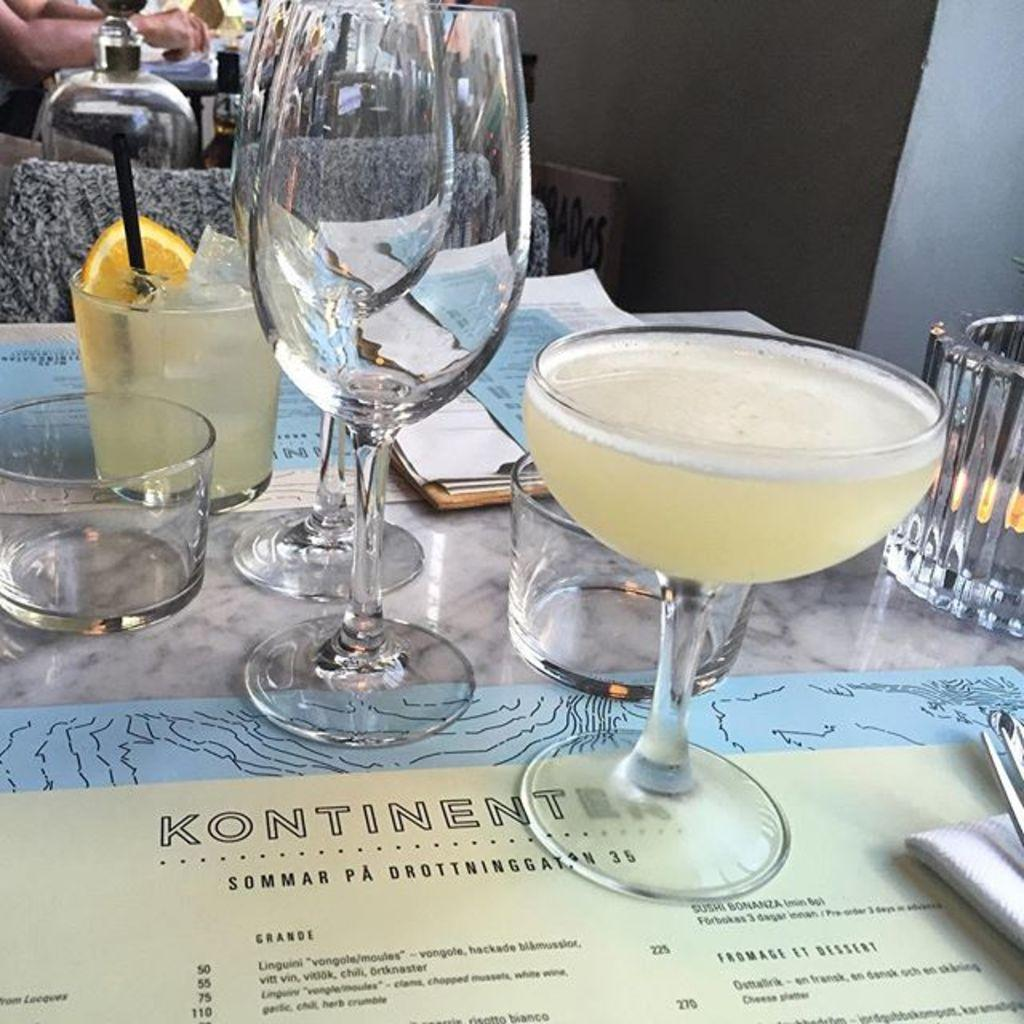What type of pest can be heard making noise near the dock in the image? There is no dock or pest present in the image, and therefore no such noise can be heard. 